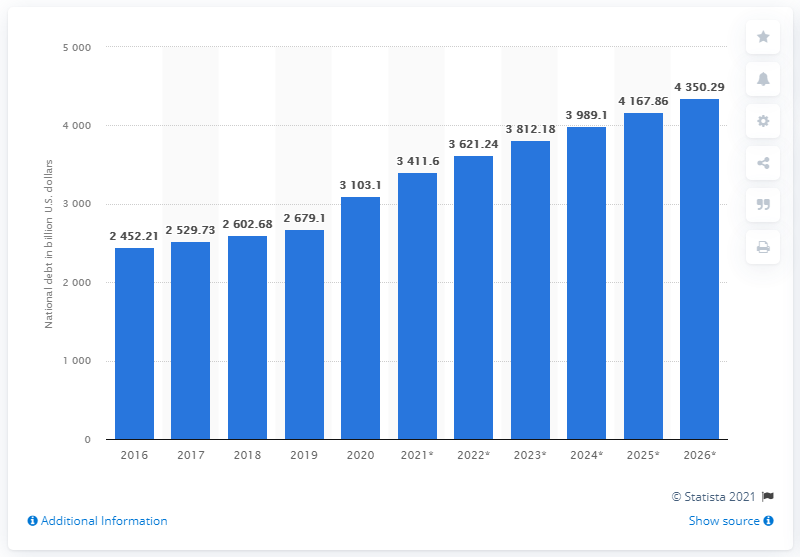Specify some key components in this picture. The national debt of the United Kingdom ended in 2020. In 2020, the national debt of the United Kingdom was approximately 3103.1 billion dollars. 